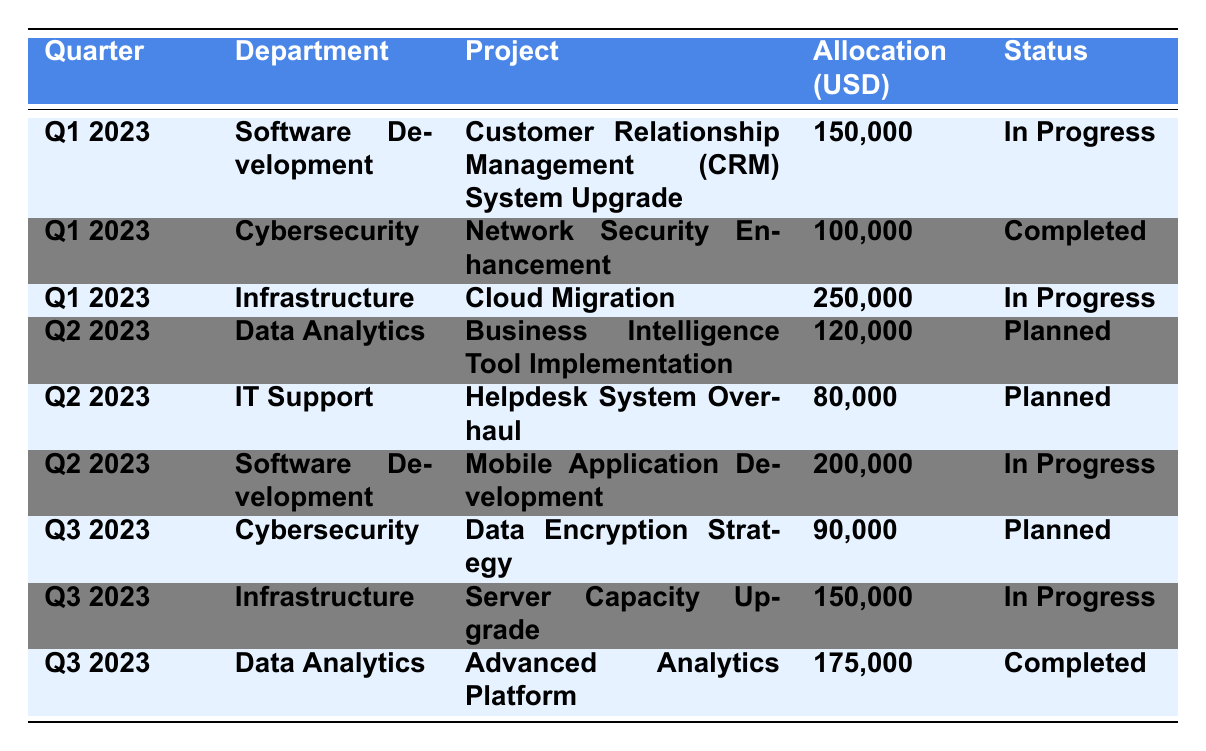What's the total budget allocated for Q1 2023? The allocations for Q1 2023 are 150,000 for Software Development, 100,000 for Cybersecurity, and 250,000 for Infrastructure. Adding these gives: 150,000 + 100,000 + 250,000 = 500,000.
Answer: 500,000 How many projects are marked as "Planned"? There are three projects planned: "Business Intelligence Tool Implementation" in Q2 2023, "Helpdesk System Overhaul" in Q2 2023, and "Data Encryption Strategy" in Q3 2023.
Answer: 3 What is the status of the "Mobile Application Development" project? The status of the "Mobile Application Development" project is listed as "In Progress" in the table.
Answer: In Progress Which department has the highest allocation in Q2 2023? In Q2 2023, Software Development has the highest allocation of 200,000 for the "Mobile Application Development" project compared to Data Analytics (120,000) and IT Support (80,000).
Answer: Software Development Is the "Cloud Migration" project completed? The status of the "Cloud Migration" project is "In Progress," indicating it is not completed.
Answer: No What is the total budget allocated across all quarters for Cybersecurity projects? The Cybersecurity projects have allocations of 100,000 in Q1 2023 and 90,000 in Q3 2023. Summing these gives: 100,000 + 90,000 = 190,000.
Answer: 190,000 What percentage of the total budget in Q2 2023 is allocated to IT Support? The total allocation for Q2 2023 is 120,000 (Data Analytics) + 80,000 (IT Support) + 200,000 (Software Development) = 400,000. The allocation for IT Support is 80,000. To find the percentage: (80,000 / 400,000) * 100 = 20%.
Answer: 20% Which project has the second highest allocation in Q1 2023? The allocations for Q1 2023 are 150,000, 100,000, and 250,000. The second highest allocation is 150,000 for "Customer Relationship Management (CRM) System Upgrade" in the Software Development department.
Answer: Customer Relationship Management (CRM) System Upgrade What is the average allocation for completed projects across all quarters? The completed projects are "Network Security Enhancement" (100,000) in Q1 2023 and "Advanced Analytics Platform" (175,000) in Q3 2023. The total allocation for completed projects is 100,000 + 175,000 = 275,000. There are 2 completed projects, so the average is 275,000 / 2 = 137,500.
Answer: 137,500 How many projects in Q3 2023 are currently "In Progress"? In Q3 2023, there are two projects "Server Capacity Upgrade" (In Progress) and "Data Encryption Strategy" (Planned). Only "Server Capacity Upgrade" is In Progress, making the total count one.
Answer: 1 